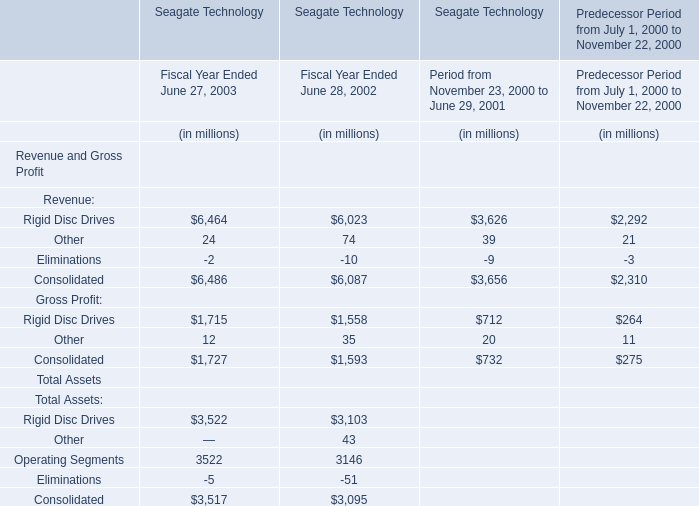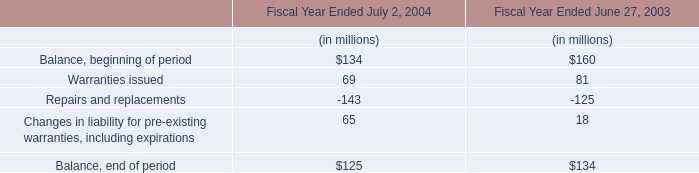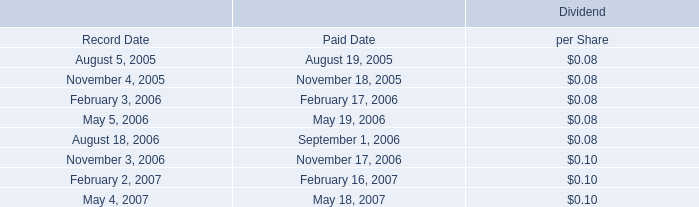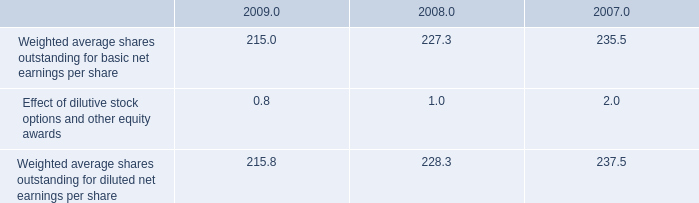In the year with largest amount of Rigid Disc Drives, what's the sum of Balance, beginning of period and Warranties issued ? (in million) 
Computations: (160 + 81)
Answer: 241.0. 